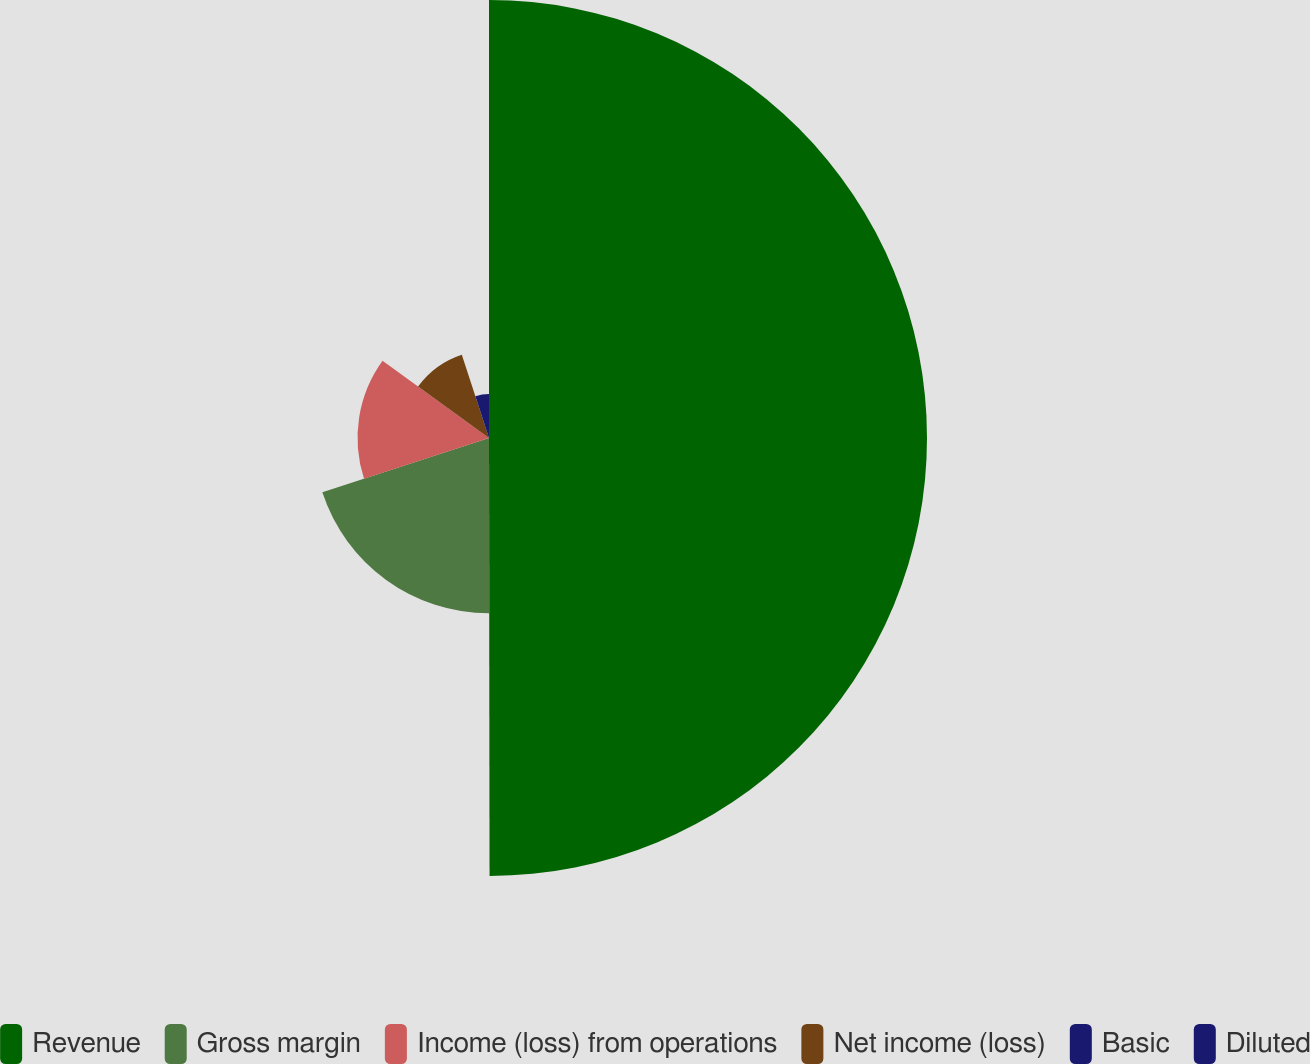Convert chart. <chart><loc_0><loc_0><loc_500><loc_500><pie_chart><fcel>Revenue<fcel>Gross margin<fcel>Income (loss) from operations<fcel>Net income (loss)<fcel>Basic<fcel>Diluted<nl><fcel>49.98%<fcel>20.0%<fcel>15.0%<fcel>10.0%<fcel>5.01%<fcel>0.01%<nl></chart> 